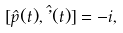Convert formula to latex. <formula><loc_0><loc_0><loc_500><loc_500>[ \hat { p } ( t ) , \hat { \varphi } ( t ) ] = - i ,</formula> 